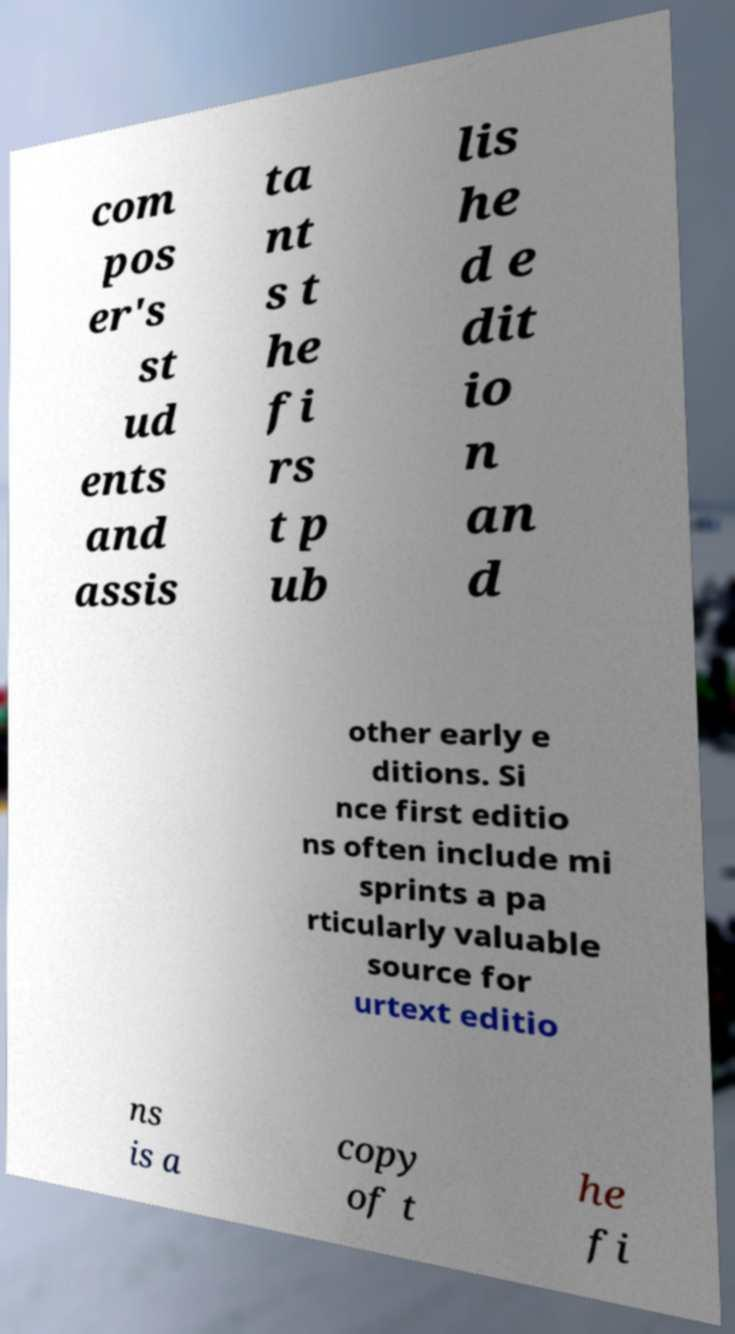Can you read and provide the text displayed in the image?This photo seems to have some interesting text. Can you extract and type it out for me? com pos er's st ud ents and assis ta nt s t he fi rs t p ub lis he d e dit io n an d other early e ditions. Si nce first editio ns often include mi sprints a pa rticularly valuable source for urtext editio ns is a copy of t he fi 